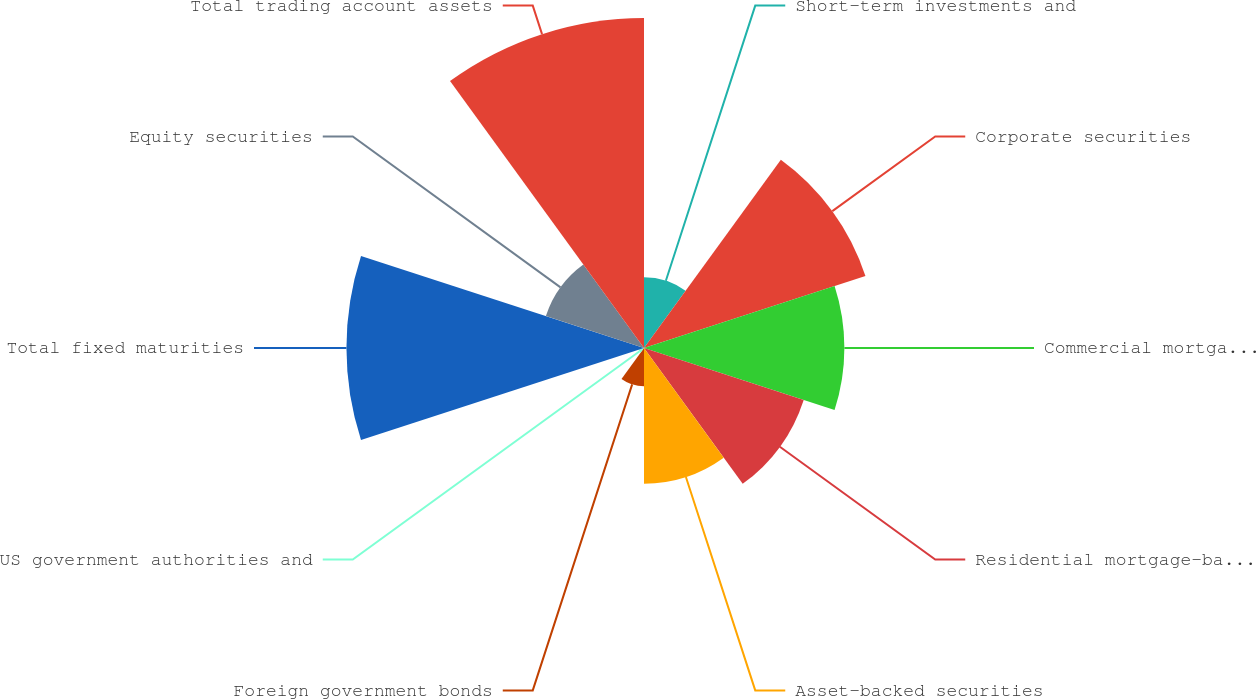Convert chart to OTSL. <chart><loc_0><loc_0><loc_500><loc_500><pie_chart><fcel>Short-term investments and<fcel>Corporate securities<fcel>Commercial mortgage-backed<fcel>Residential mortgage-backed<fcel>Asset-backed securities<fcel>Foreign government bonds<fcel>US government authorities and<fcel>Total fixed maturities<fcel>Equity securities<fcel>Total trading account assets<nl><fcel>4.47%<fcel>14.71%<fcel>12.66%<fcel>10.61%<fcel>8.57%<fcel>2.42%<fcel>0.37%<fcel>18.8%<fcel>6.52%<fcel>20.85%<nl></chart> 